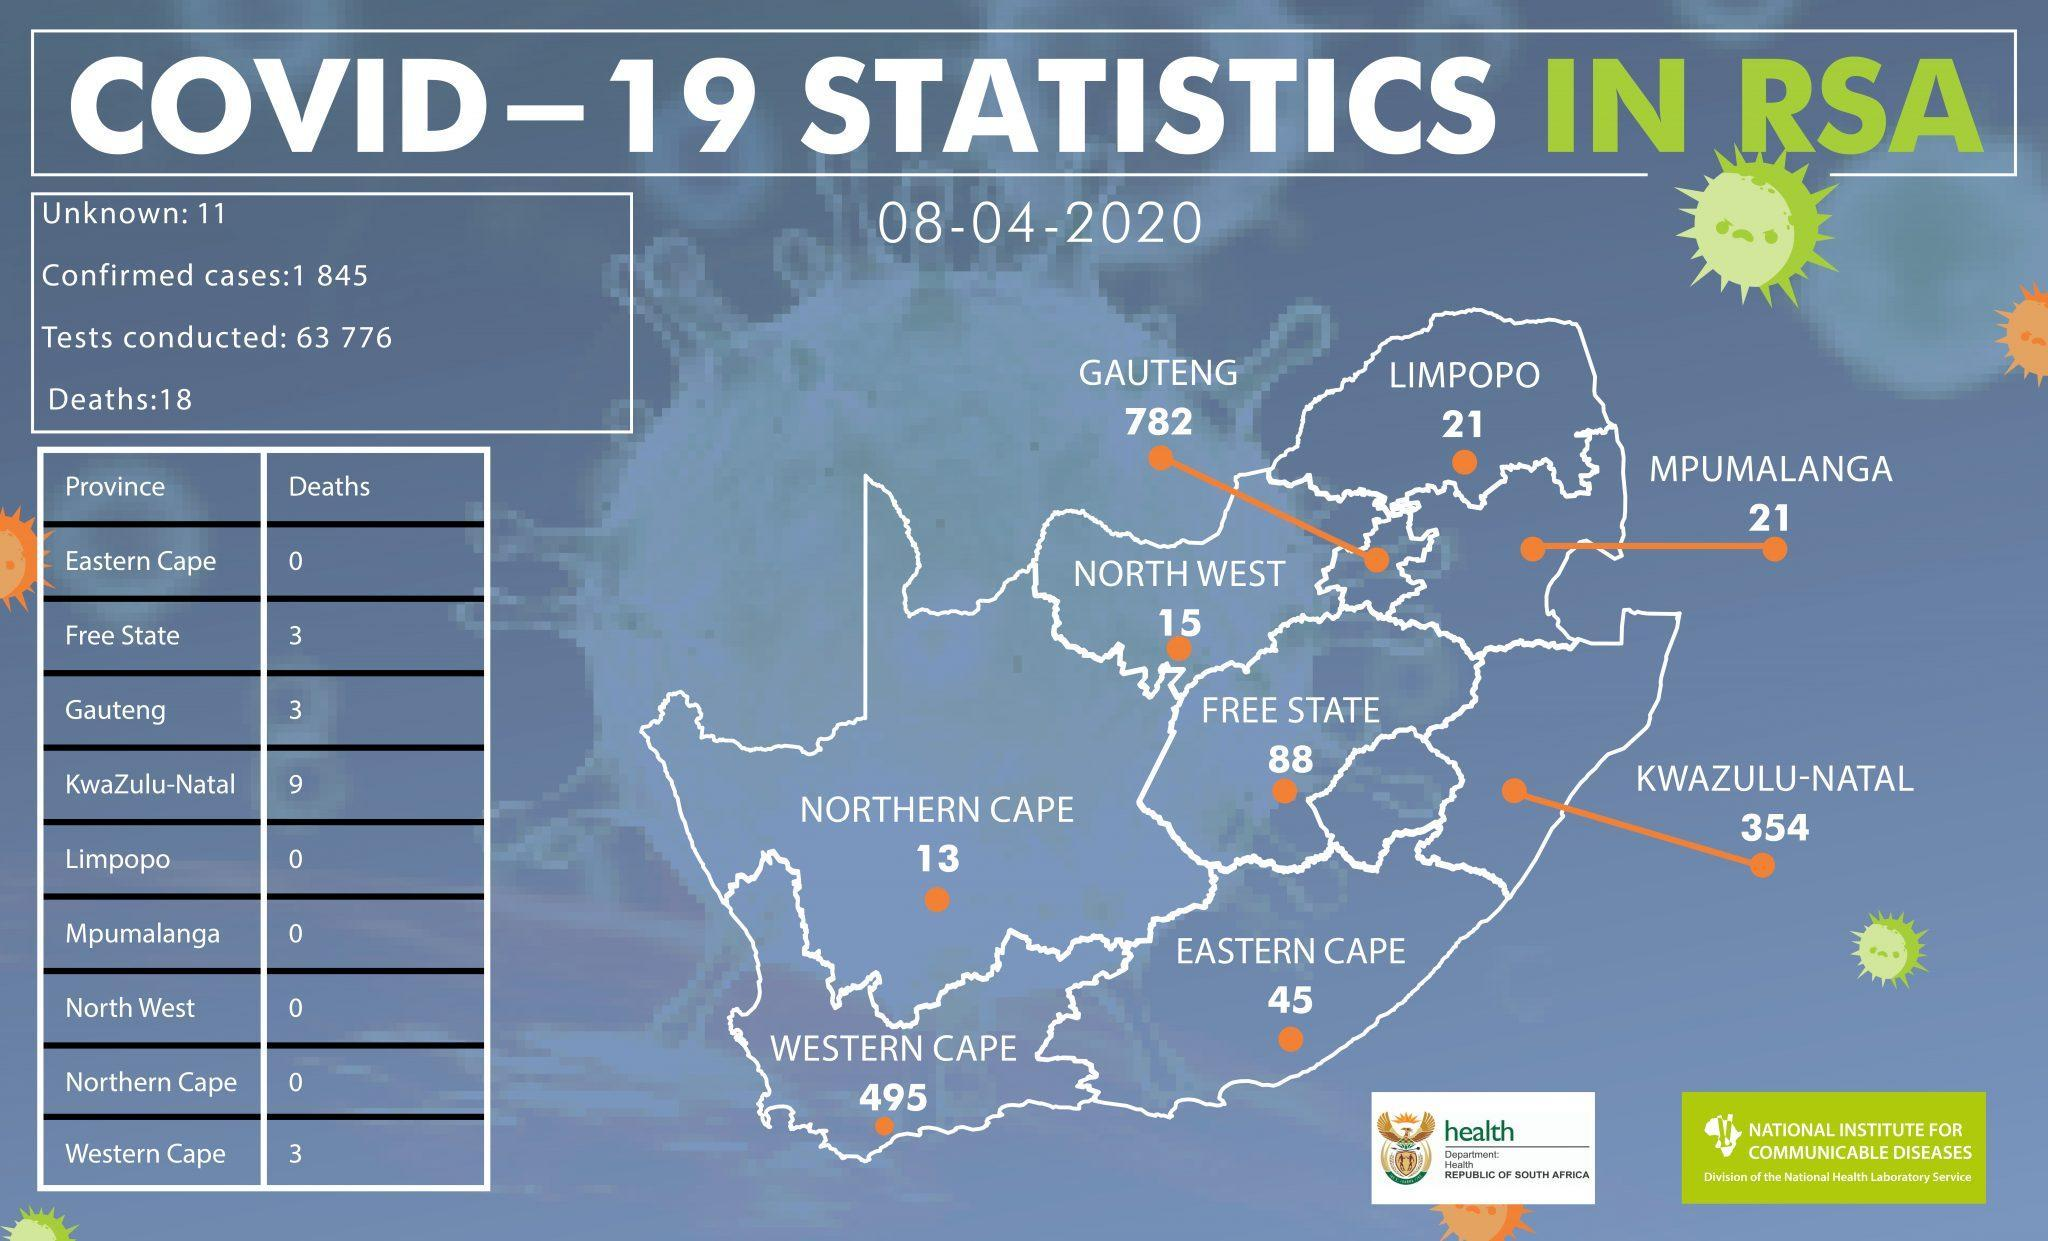Which provinces had a death count of 3
Answer the question with a short phrase. Free state, Gauteng, Western Cape What is the total number of deaths in Eastern Cape, Northern Cape and Western Cape 3 What is the total confirmed case count of Western Cape, Eastern Cape and Northern Cape 553 WHich province recorded 50% of the deaths KwaZulu-Natal WHich provinces have a confirmed case of 21 Limpopo, Mpumalanga WHich provice has the second highest Covid count Western Cape 